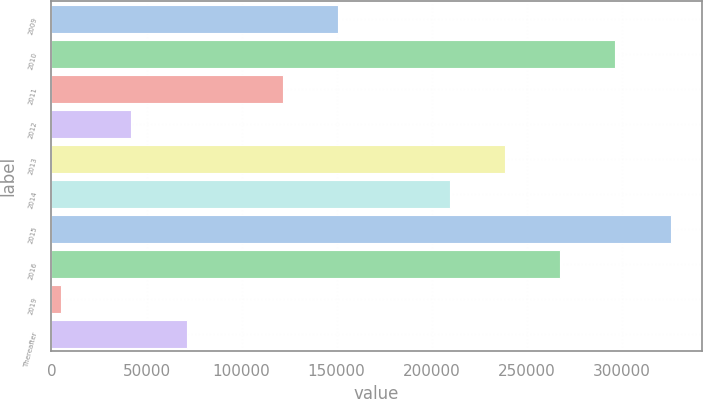<chart> <loc_0><loc_0><loc_500><loc_500><bar_chart><fcel>2009<fcel>2010<fcel>2011<fcel>2012<fcel>2013<fcel>2014<fcel>2015<fcel>2016<fcel>2019<fcel>Thereafter<nl><fcel>150827<fcel>296727<fcel>121813<fcel>42076<fcel>238698<fcel>209684<fcel>325742<fcel>267713<fcel>4831<fcel>71090.4<nl></chart> 